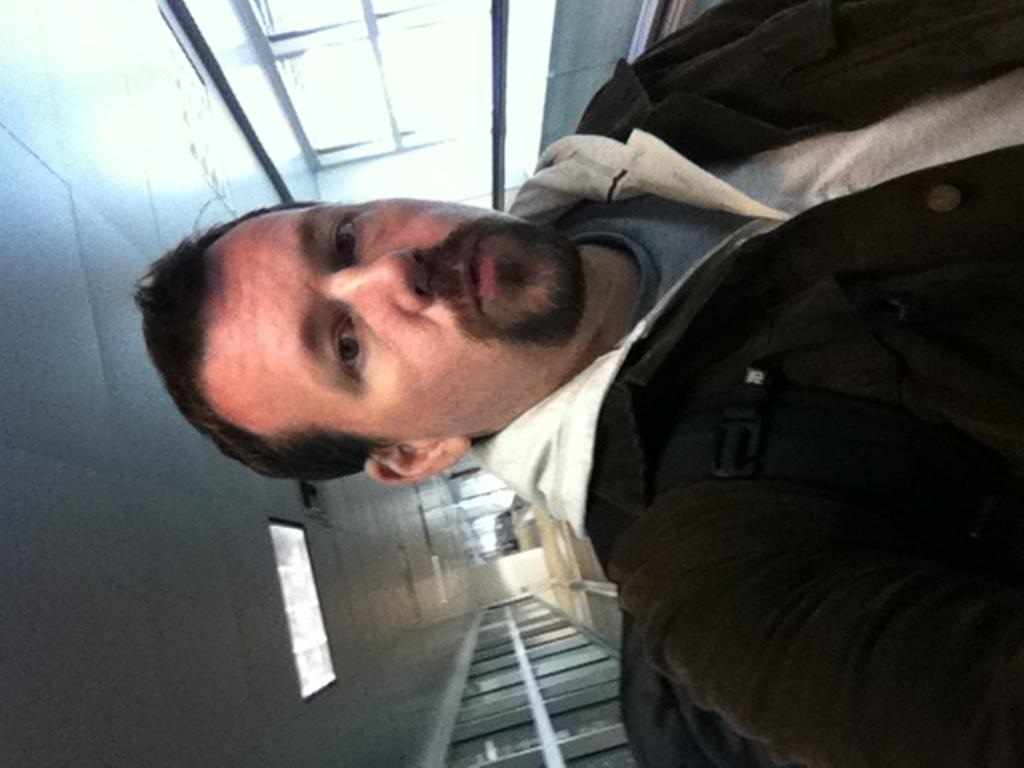Who is present in the image? There is a man in the image. What is on top of the man? There is a light on top of the man. How many horses are visible in the image? There are no horses present in the image. What role does the man's mother play in the image? The man's mother is not mentioned or visible in the image. 